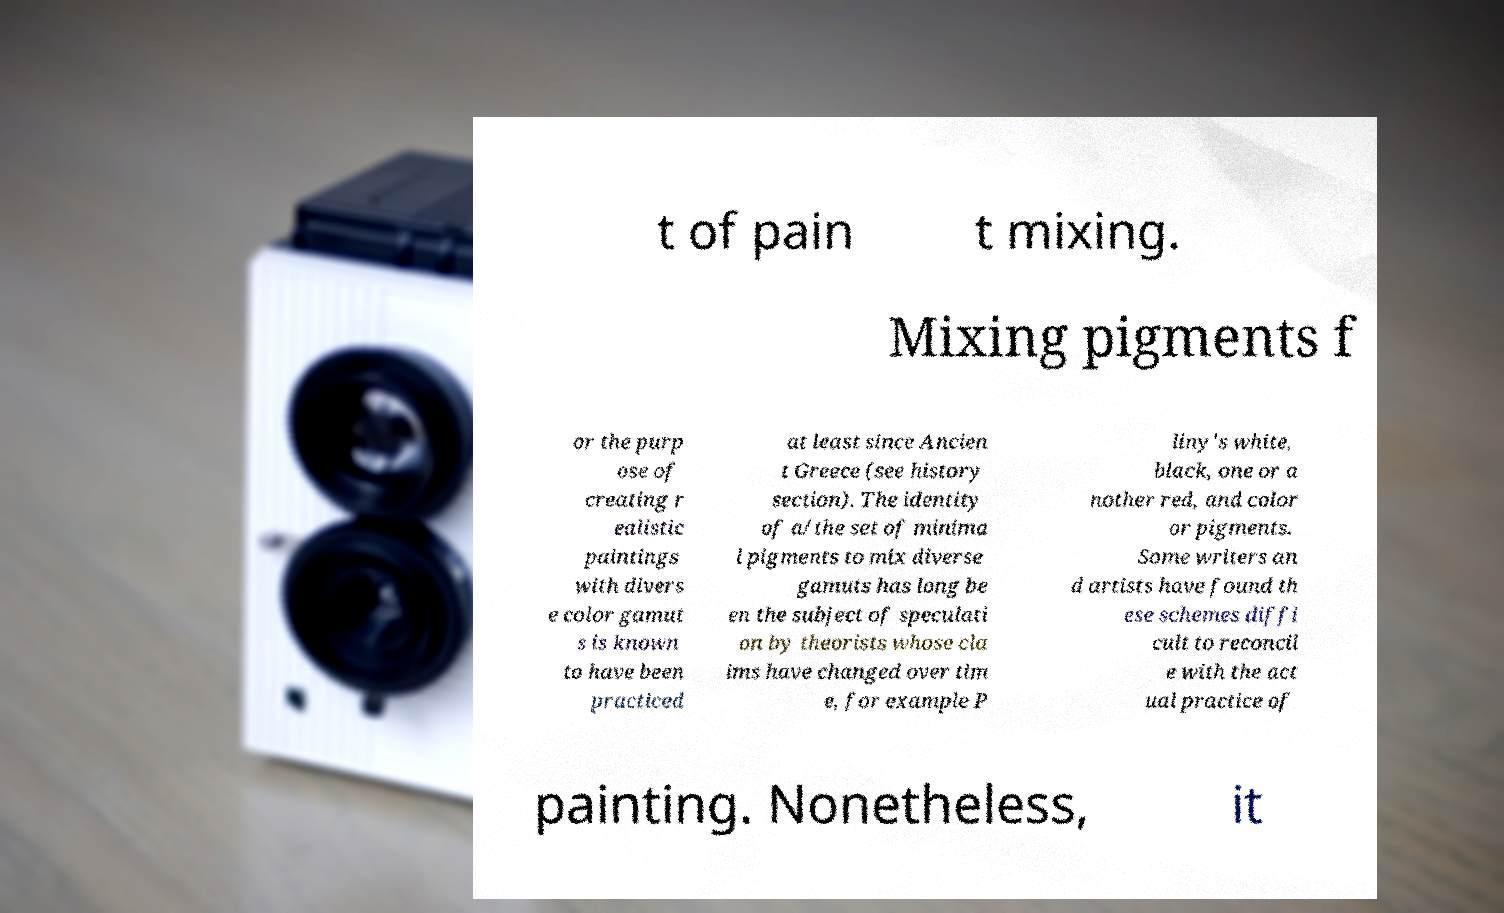There's text embedded in this image that I need extracted. Can you transcribe it verbatim? t of pain t mixing. Mixing pigments f or the purp ose of creating r ealistic paintings with divers e color gamut s is known to have been practiced at least since Ancien t Greece (see history section). The identity of a/the set of minima l pigments to mix diverse gamuts has long be en the subject of speculati on by theorists whose cla ims have changed over tim e, for example P liny's white, black, one or a nother red, and color or pigments. Some writers an d artists have found th ese schemes diffi cult to reconcil e with the act ual practice of painting. Nonetheless, it 